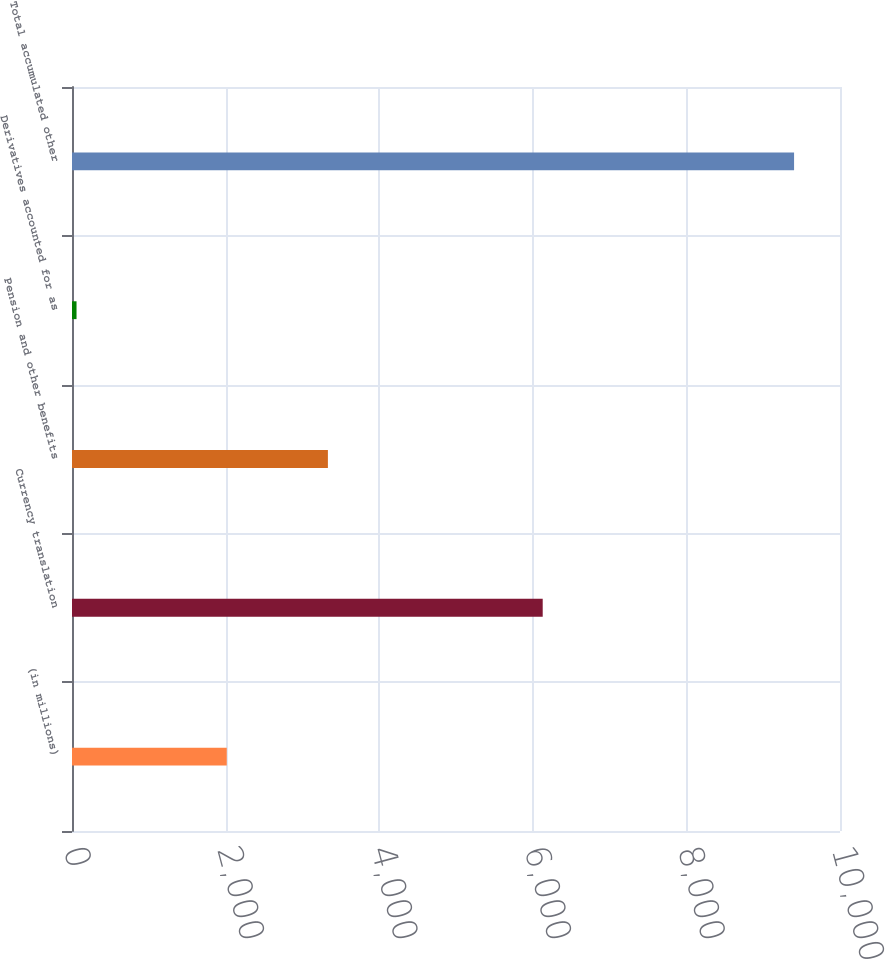<chart> <loc_0><loc_0><loc_500><loc_500><bar_chart><fcel>(in millions)<fcel>Currency translation<fcel>Pension and other benefits<fcel>Derivatives accounted for as<fcel>Total accumulated other<nl><fcel>2015<fcel>6129<fcel>3332<fcel>59<fcel>9402<nl></chart> 